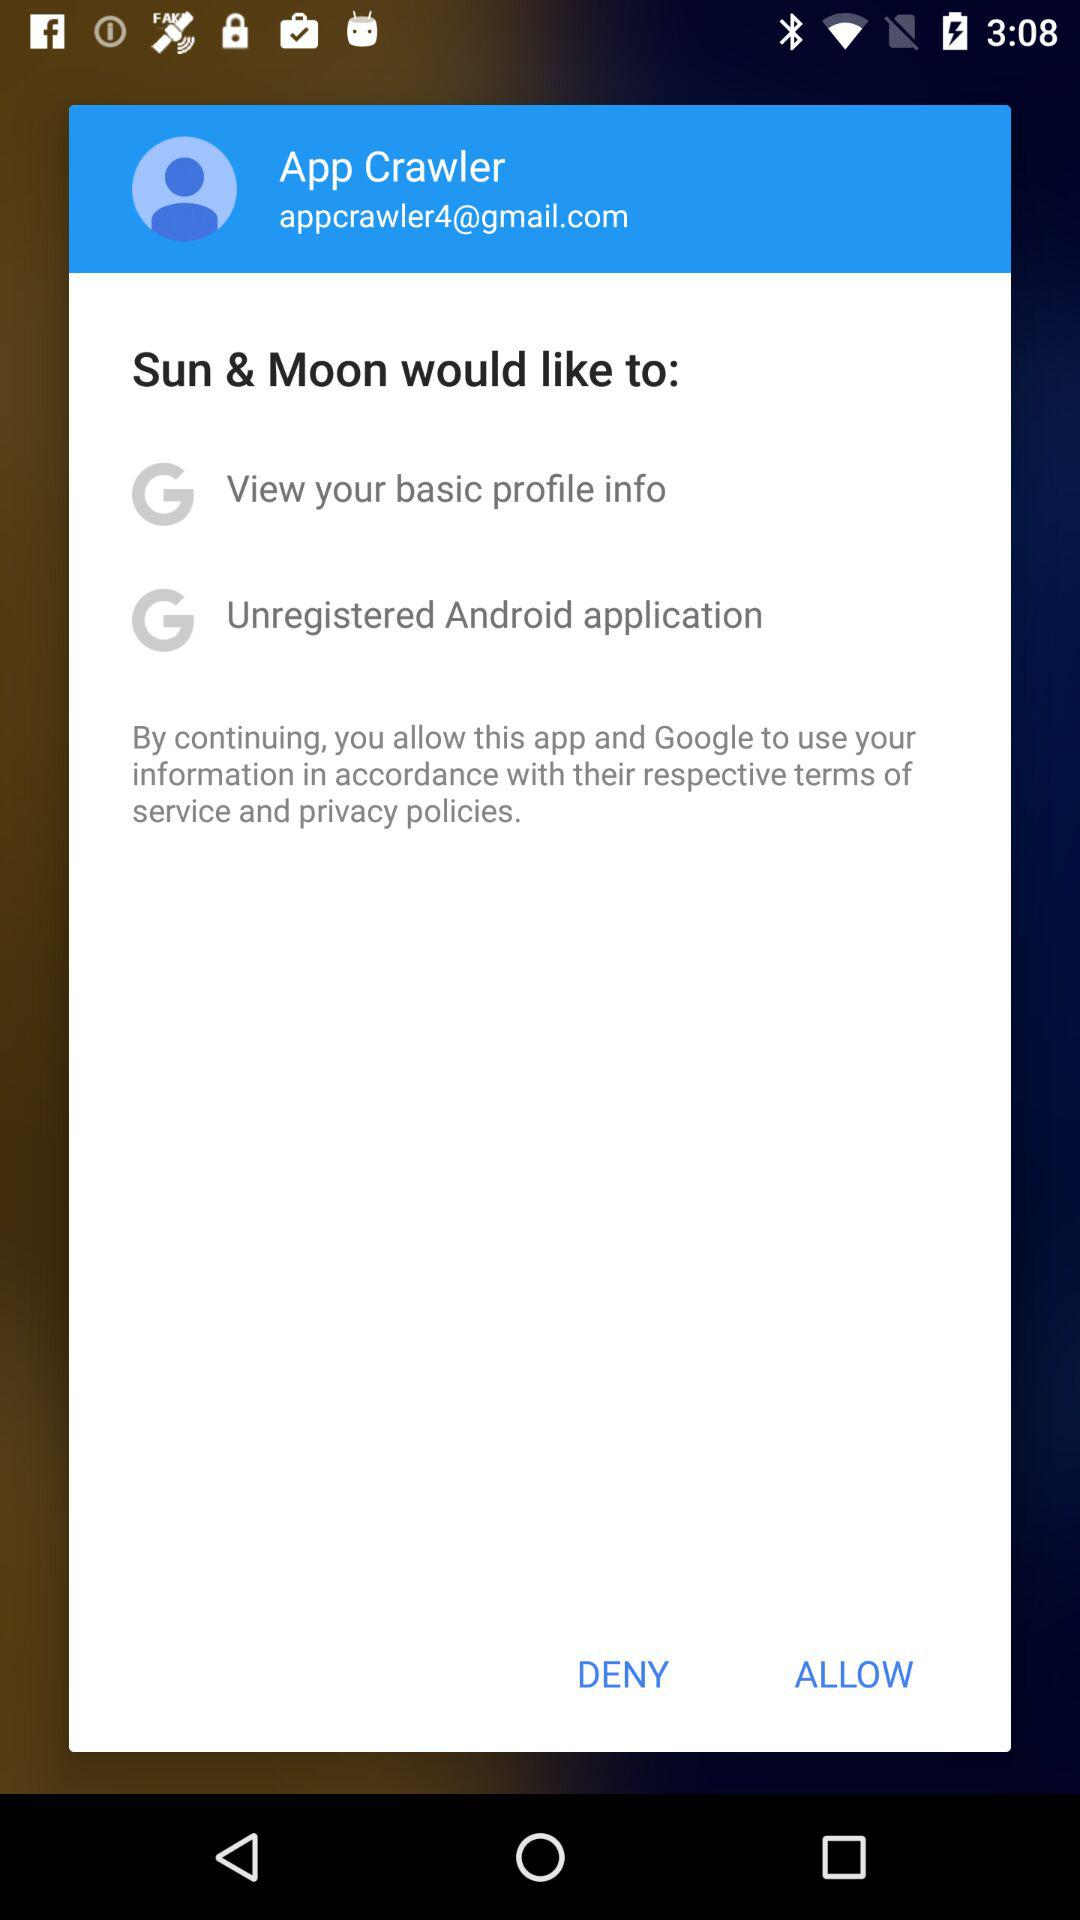What is the name of the user? The name of the user is App Crawler. 